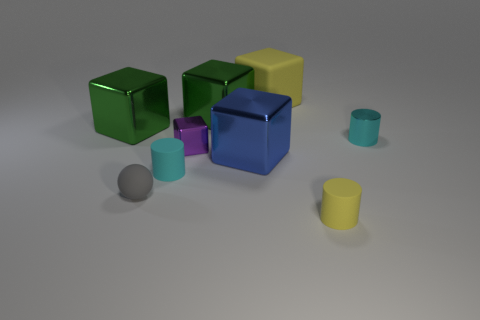What size is the cube that is both to the right of the purple cube and in front of the tiny metal cylinder?
Ensure brevity in your answer.  Large. What number of small yellow things are made of the same material as the blue block?
Your answer should be very brief. 0. What is the shape of the tiny matte thing that is the same color as the rubber cube?
Keep it short and to the point. Cylinder. The small ball is what color?
Your answer should be compact. Gray. Does the tiny cyan object to the right of the yellow cube have the same shape as the blue metal thing?
Your answer should be compact. No. What number of objects are either objects that are behind the tiny yellow object or gray spheres?
Your response must be concise. 8. Is there a tiny yellow thing that has the same shape as the blue metal thing?
Keep it short and to the point. No. What is the shape of the cyan shiny object that is the same size as the ball?
Offer a terse response. Cylinder. There is a tiny cyan object that is left of the tiny rubber object that is on the right side of the yellow rubber thing behind the purple metal thing; what shape is it?
Make the answer very short. Cylinder. Does the small cyan matte object have the same shape as the large object in front of the tiny cyan shiny cylinder?
Your answer should be compact. No. 